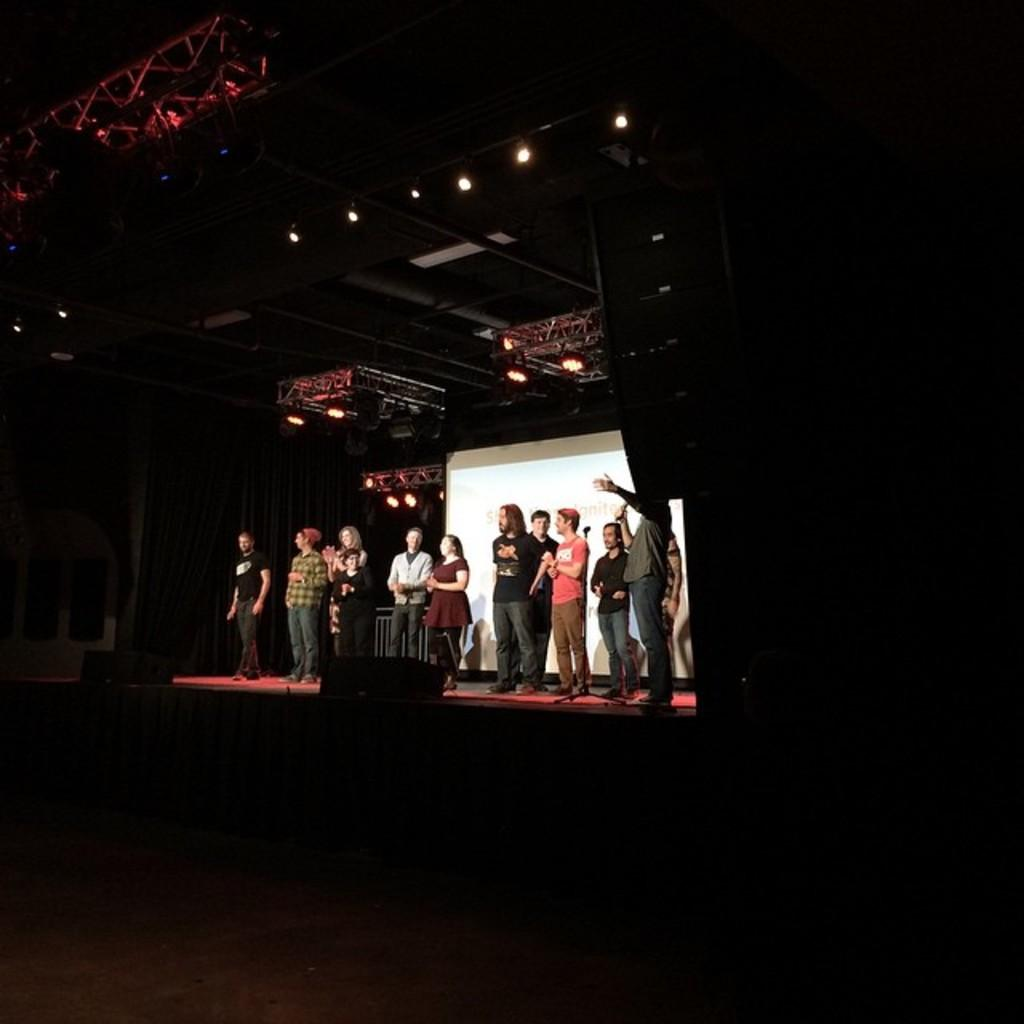What is the main feature of the image? There is a stage in the image. What can be seen on the stage? There are many people standing on the stage, as well as speakers. What is located behind the stage? There is a curtain and a white screen in the back of the stage. What is present on top of the stage? There are lights on the top of the stage. How many forks can be seen on the stage in the image? There are no forks present on the stage in the image. Can you tell me how many cats are sitting on the white screen in the image? There are no cats present on the white screen or anywhere else in the image. 